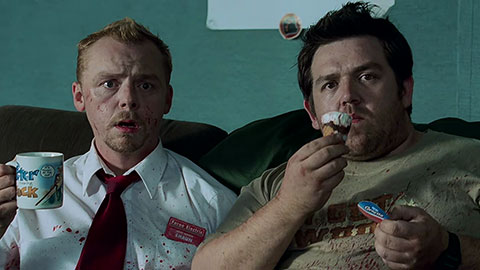What can you infer about the situation in this image? From the expressions and body language of the characters, it appears they have just witnessed something alarming or unexpected. The blood on Shaun's shirt and face suggests a recent violent encounter, possibly with zombies, as the movie 'Shaun of the Dead' deals with a zombie apocalypse. Despite the apparent chaos, there is a humorous undertone seen in Ed holding an ice cream cone and a mug with a humorous message. This mix of horror and comedy is a hallmark of the film. Can you provide more context about this scene in the movie? This scene is from 'Shaun of the Dead', a British horror-comedy film. The story follows Shaun, a down-on-his-luck salesman, who is trying to sort out his life while dealing with a sudden zombie apocalypse. In this particular moment, Shaun and his best friend Ed have likely just had a run-in with zombies, as evidenced by the blood. They are taking a moment to regroup, showing their characteristic resilience and humor even in dire situations. This image captures the essence of the film's blend of mundane life and dramatic horror, highlighting the characters' unique approaches to the bizarre events unfolding around them. 